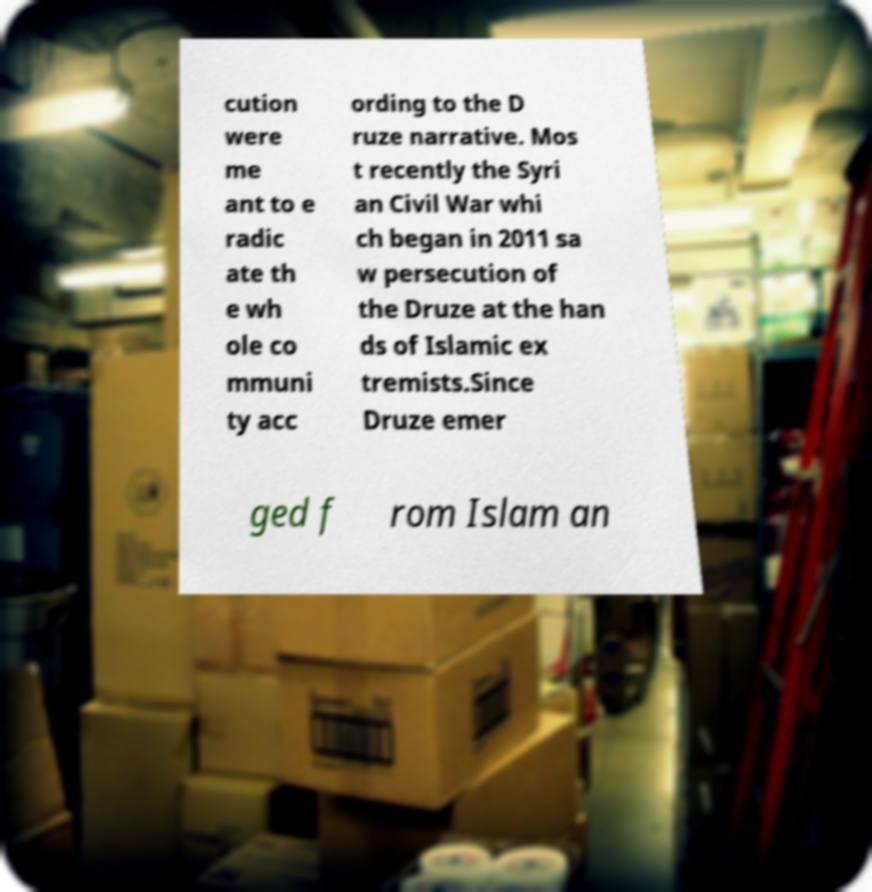I need the written content from this picture converted into text. Can you do that? cution were me ant to e radic ate th e wh ole co mmuni ty acc ording to the D ruze narrative. Mos t recently the Syri an Civil War whi ch began in 2011 sa w persecution of the Druze at the han ds of Islamic ex tremists.Since Druze emer ged f rom Islam an 